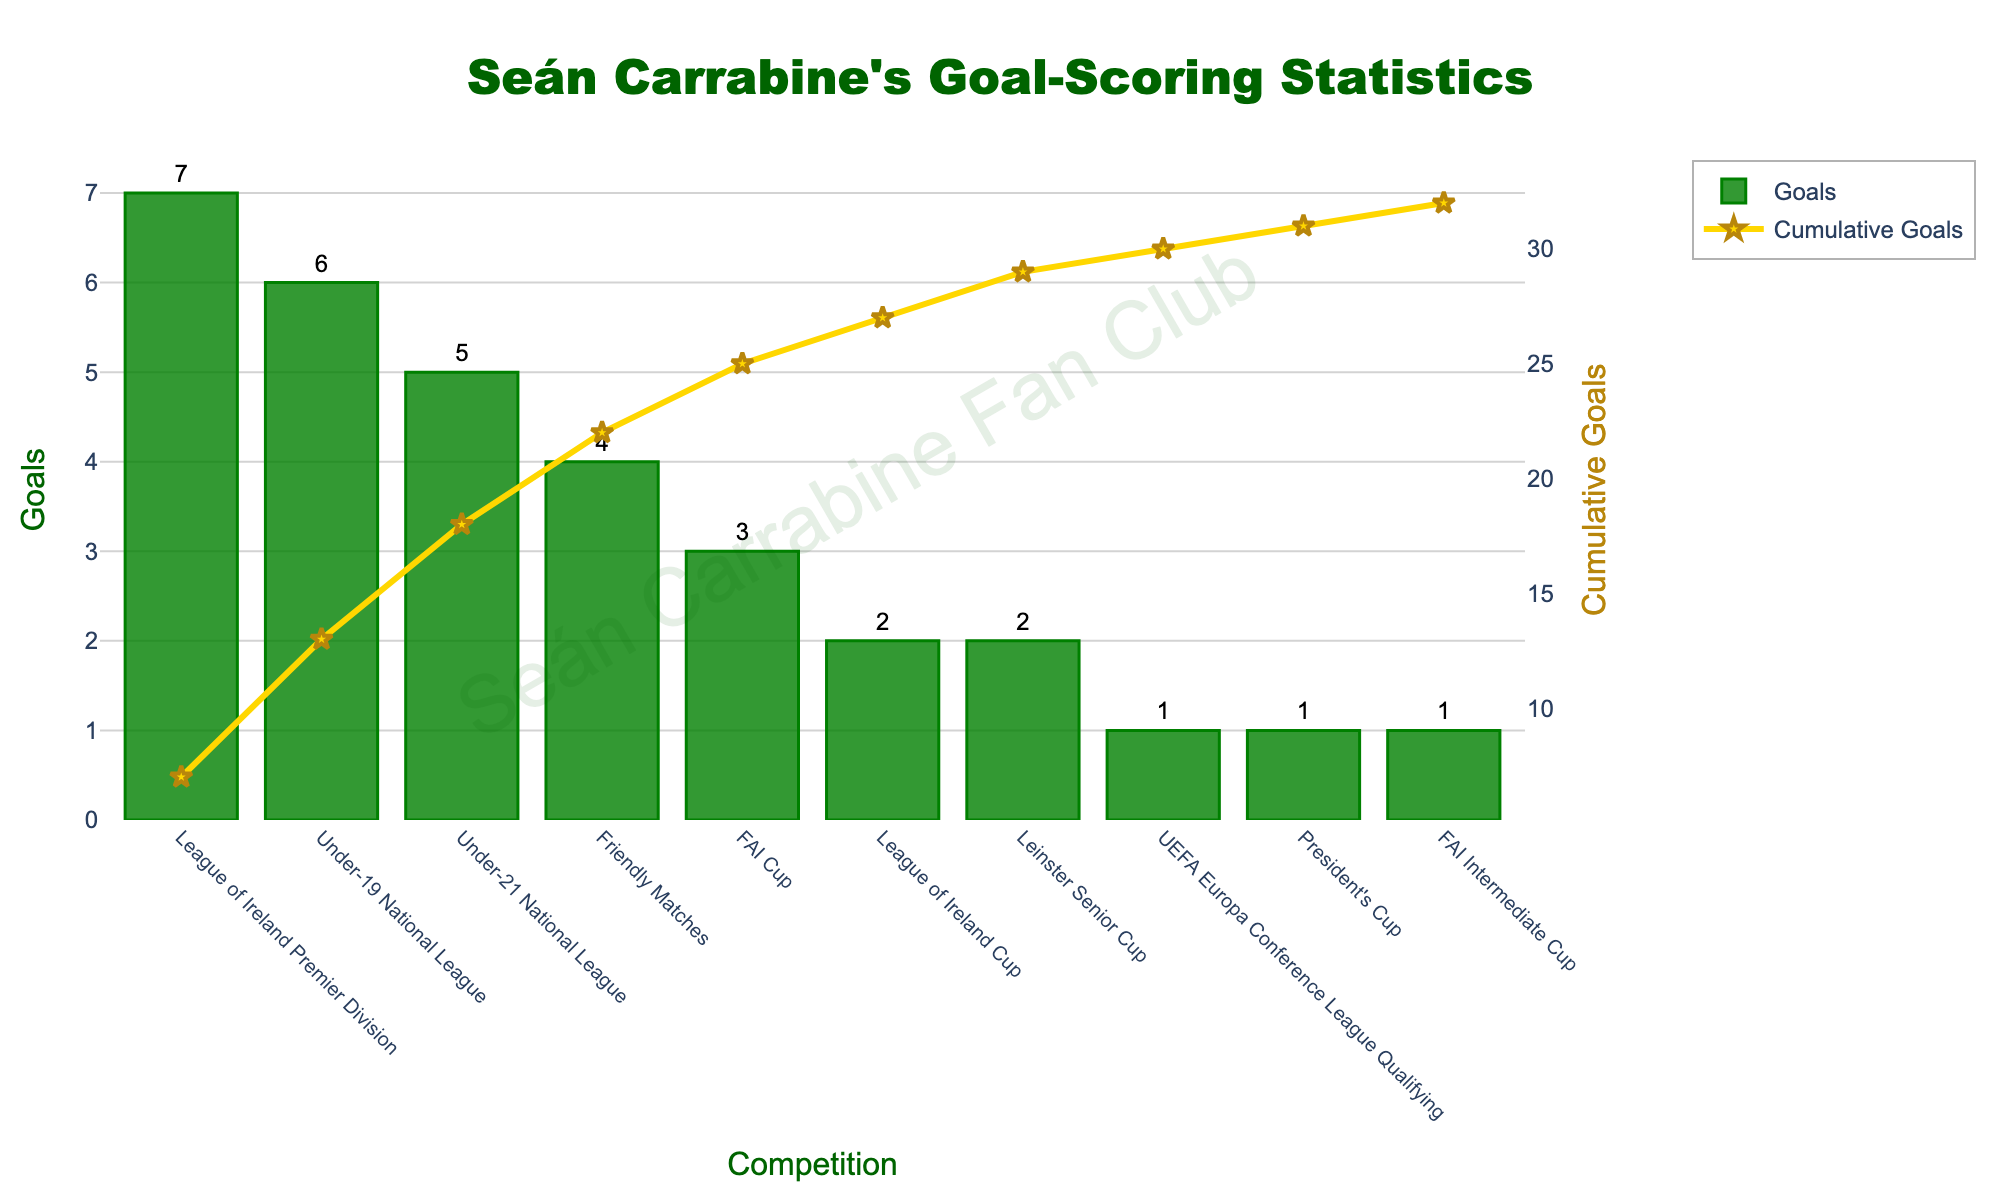What is the competition in which Seán Carrabine scored the highest number of goals? The competition with the highest bar represents the highest number of goals. The tallest bar belongs to the "League of Ireland Premier Division" with 7 goals.
Answer: League of Ireland Premier Division How many goals did Seán Carrabine score in total in the Under-19 National League and Under-21 National League combined? Seán Carrabine scored 6 goals in the Under-19 National League and 5 goals in the Under-21 National League. Adding these together gives 6 + 5 = 11 goals.
Answer: 11 Which competition has a higher number of goals scored by Seán Carrabine: the FAI Cup or the Friendly Matches? By comparing the height of the bars for the FAI Cup and the Friendly Matches, we see that the Friendly Matches bar is taller with 4 goals, whereas the FAI Cup has 3 goals.
Answer: Friendly Matches What is the cumulative number of goals after the FAI Cup in the sorted order? The cumulative number of goals for each competition is plotted using a golden line. The order after sorting starts with the League of Ireland Premier Division. Summing up the goals until the FAI Cup: (7 for League of Ireland Premier Division + 6 for Under-19 National League + 5 for Under-21 National League + 4 for Friendly Matches + 3 for FAI Cup) gives 25.
Answer: 25 In which competition did Seán Carrabine score twice and have a cumulative goal count of 18 before the start of that competition? The bar plot shows that Seán Carrabine scored 2 goals in the League of Ireland Cup and Leinster Senior Cup. The cumulative goal line reaches 18 after adding the goals for Under-21 National League (5), Under-19 National League (6), and League of Ireland Premier Division (7). Thus, the next competition where he scored 2 goals is the League of Ireland Cup.
Answer: League of Ireland Cup What is the cumulative number of goals at the end of the competition list? The cumulative goals line reaches its highest value at the end of the list. Adding all goals across the competitions: (7 + 6 + 5 + 4 + 3 + 2 + 2 + 1 + 1 + 1) gives a total of 32.
Answer: 32 Between Leinster Senior Cup and President's Cup, which competition has fewer goals and by how many? Comparing the heights of the bars for Leinster Senior Cup and President's Cup shows that the President's Cup has 1 goal, while the Leinster Senior Cup has 2 goals. The difference is 2 - 1 = 1 goal.
Answer: President's Cup, 1 goal What is the color used for the cumulative goals line, and what marker symbolizes it? The cumulative goals are represented by a golden line with star-shaped markers as observed from the legend and the plot.
Answer: Golden, star markers 